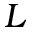<formula> <loc_0><loc_0><loc_500><loc_500>L</formula> 